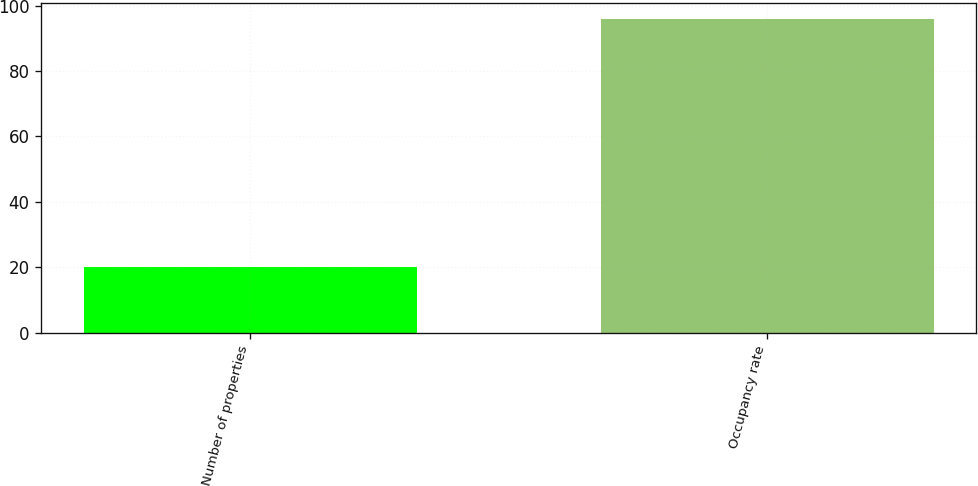<chart> <loc_0><loc_0><loc_500><loc_500><bar_chart><fcel>Number of properties<fcel>Occupancy rate<nl><fcel>20<fcel>96<nl></chart> 